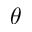<formula> <loc_0><loc_0><loc_500><loc_500>\theta</formula> 